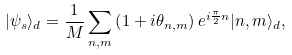<formula> <loc_0><loc_0><loc_500><loc_500>| \psi _ { s } \rangle _ { d } = \frac { 1 } { M } \sum _ { n , m } \left ( 1 + i \theta _ { n , m } \right ) e ^ { i \frac { \pi } { 2 } n } | n , m \rangle _ { d } ,</formula> 